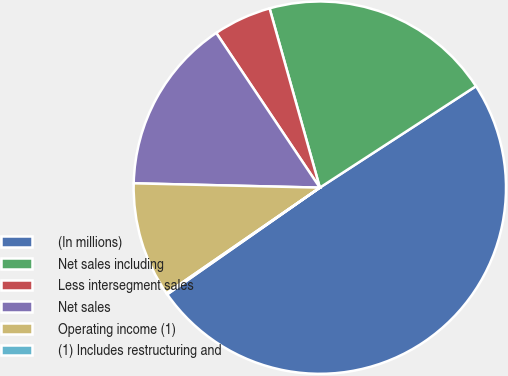<chart> <loc_0><loc_0><loc_500><loc_500><pie_chart><fcel>(In millions)<fcel>Net sales including<fcel>Less intersegment sales<fcel>Net sales<fcel>Operating income (1)<fcel>(1) Includes restructuring and<nl><fcel>49.46%<fcel>20.18%<fcel>5.04%<fcel>15.24%<fcel>9.98%<fcel>0.1%<nl></chart> 